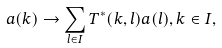<formula> <loc_0><loc_0><loc_500><loc_500>a ( k ) \to \sum _ { l \in I } T ^ { * } ( k , l ) a ( l ) , k \in I ,</formula> 